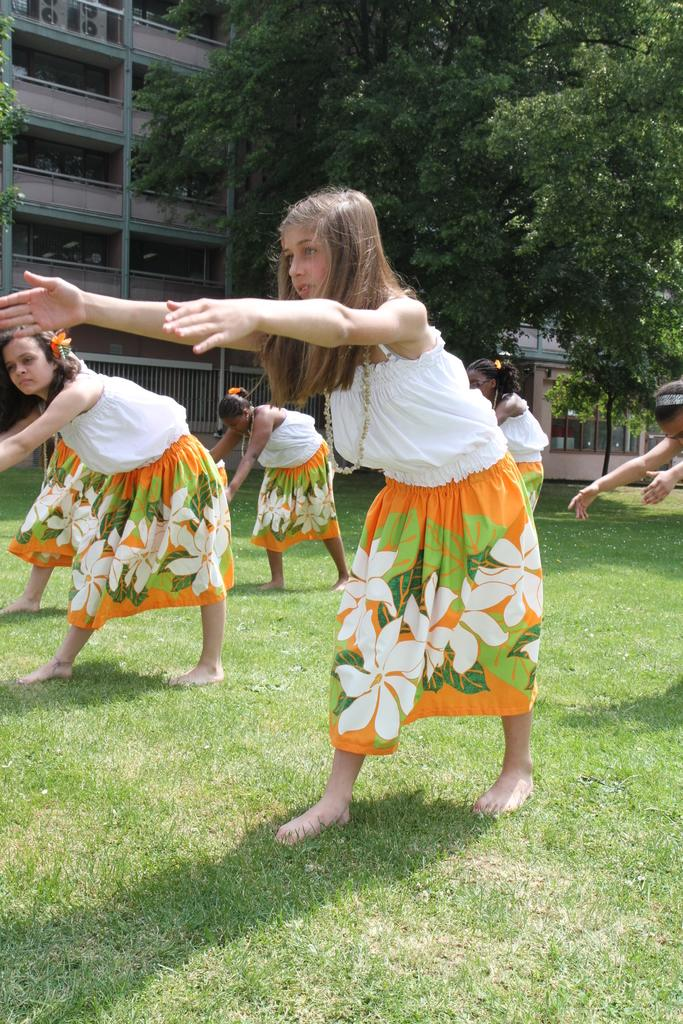Who is present in the image? There are women in the image. What are the women doing in the image? The women appear to be exercising in the image. Where are the women located in the image? The women are standing on the grass in the image. What can be seen in the background of the image? There is a building and trees in the background of the image. What type of skirt is the lizard wearing in the image? There are no lizards present in the image, and therefore no lizards wearing skirts. 